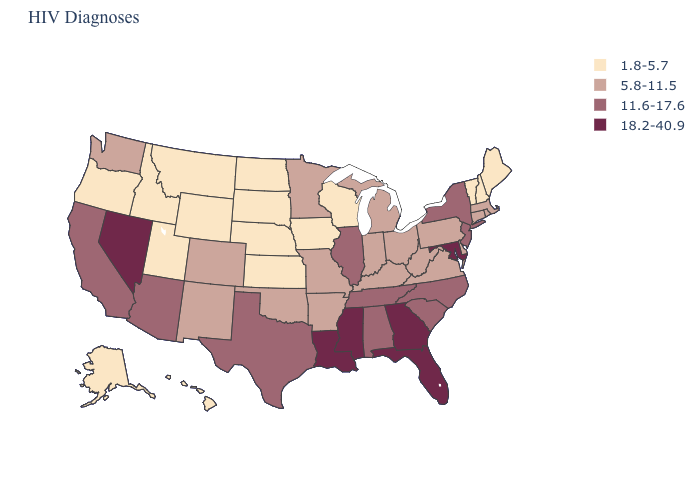Is the legend a continuous bar?
Give a very brief answer. No. Which states hav the highest value in the Northeast?
Keep it brief. New Jersey, New York. Which states have the lowest value in the USA?
Concise answer only. Alaska, Hawaii, Idaho, Iowa, Kansas, Maine, Montana, Nebraska, New Hampshire, North Dakota, Oregon, South Dakota, Utah, Vermont, Wisconsin, Wyoming. What is the value of Kentucky?
Concise answer only. 5.8-11.5. Name the states that have a value in the range 5.8-11.5?
Write a very short answer. Arkansas, Colorado, Connecticut, Delaware, Indiana, Kentucky, Massachusetts, Michigan, Minnesota, Missouri, New Mexico, Ohio, Oklahoma, Pennsylvania, Rhode Island, Virginia, Washington, West Virginia. Among the states that border Kentucky , which have the lowest value?
Concise answer only. Indiana, Missouri, Ohio, Virginia, West Virginia. Name the states that have a value in the range 18.2-40.9?
Give a very brief answer. Florida, Georgia, Louisiana, Maryland, Mississippi, Nevada. What is the value of Pennsylvania?
Concise answer only. 5.8-11.5. Does Iowa have the lowest value in the MidWest?
Write a very short answer. Yes. Does North Dakota have the lowest value in the MidWest?
Write a very short answer. Yes. Which states have the highest value in the USA?
Be succinct. Florida, Georgia, Louisiana, Maryland, Mississippi, Nevada. Does Idaho have the lowest value in the West?
Short answer required. Yes. What is the value of West Virginia?
Keep it brief. 5.8-11.5. Name the states that have a value in the range 1.8-5.7?
Answer briefly. Alaska, Hawaii, Idaho, Iowa, Kansas, Maine, Montana, Nebraska, New Hampshire, North Dakota, Oregon, South Dakota, Utah, Vermont, Wisconsin, Wyoming. 